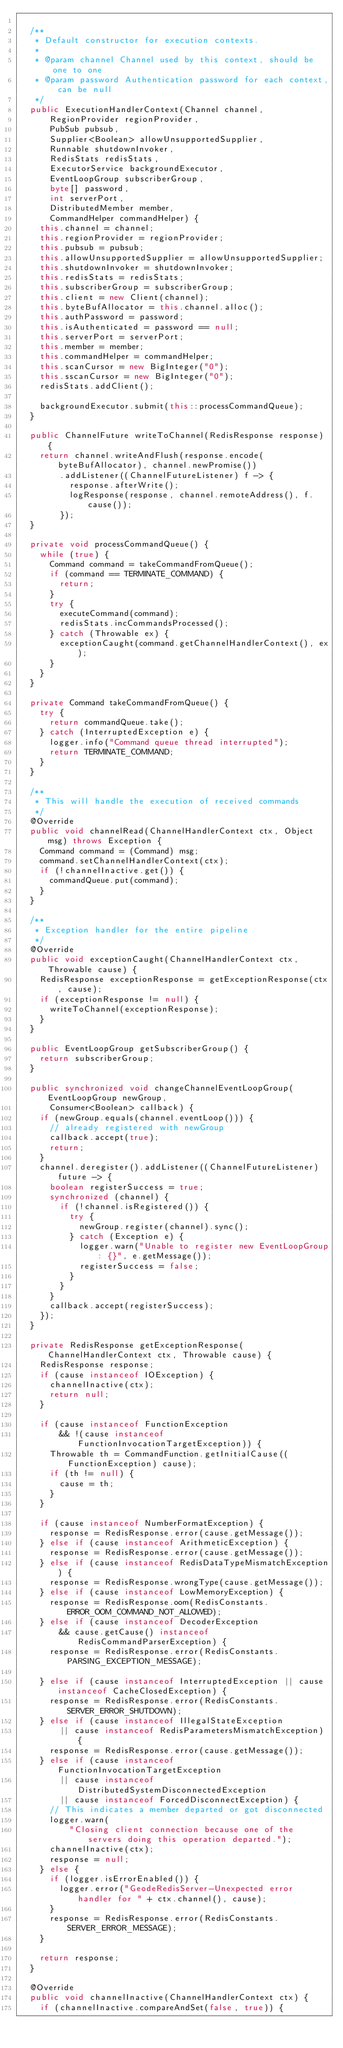<code> <loc_0><loc_0><loc_500><loc_500><_Java_>
  /**
   * Default constructor for execution contexts.
   *
   * @param channel Channel used by this context, should be one to one
   * @param password Authentication password for each context, can be null
   */
  public ExecutionHandlerContext(Channel channel,
      RegionProvider regionProvider,
      PubSub pubsub,
      Supplier<Boolean> allowUnsupportedSupplier,
      Runnable shutdownInvoker,
      RedisStats redisStats,
      ExecutorService backgroundExecutor,
      EventLoopGroup subscriberGroup,
      byte[] password,
      int serverPort,
      DistributedMember member,
      CommandHelper commandHelper) {
    this.channel = channel;
    this.regionProvider = regionProvider;
    this.pubsub = pubsub;
    this.allowUnsupportedSupplier = allowUnsupportedSupplier;
    this.shutdownInvoker = shutdownInvoker;
    this.redisStats = redisStats;
    this.subscriberGroup = subscriberGroup;
    this.client = new Client(channel);
    this.byteBufAllocator = this.channel.alloc();
    this.authPassword = password;
    this.isAuthenticated = password == null;
    this.serverPort = serverPort;
    this.member = member;
    this.commandHelper = commandHelper;
    this.scanCursor = new BigInteger("0");
    this.sscanCursor = new BigInteger("0");
    redisStats.addClient();

    backgroundExecutor.submit(this::processCommandQueue);
  }

  public ChannelFuture writeToChannel(RedisResponse response) {
    return channel.writeAndFlush(response.encode(byteBufAllocator), channel.newPromise())
        .addListener((ChannelFutureListener) f -> {
          response.afterWrite();
          logResponse(response, channel.remoteAddress(), f.cause());
        });
  }

  private void processCommandQueue() {
    while (true) {
      Command command = takeCommandFromQueue();
      if (command == TERMINATE_COMMAND) {
        return;
      }
      try {
        executeCommand(command);
        redisStats.incCommandsProcessed();
      } catch (Throwable ex) {
        exceptionCaught(command.getChannelHandlerContext(), ex);
      }
    }
  }

  private Command takeCommandFromQueue() {
    try {
      return commandQueue.take();
    } catch (InterruptedException e) {
      logger.info("Command queue thread interrupted");
      return TERMINATE_COMMAND;
    }
  }

  /**
   * This will handle the execution of received commands
   */
  @Override
  public void channelRead(ChannelHandlerContext ctx, Object msg) throws Exception {
    Command command = (Command) msg;
    command.setChannelHandlerContext(ctx);
    if (!channelInactive.get()) {
      commandQueue.put(command);
    }
  }

  /**
   * Exception handler for the entire pipeline
   */
  @Override
  public void exceptionCaught(ChannelHandlerContext ctx, Throwable cause) {
    RedisResponse exceptionResponse = getExceptionResponse(ctx, cause);
    if (exceptionResponse != null) {
      writeToChannel(exceptionResponse);
    }
  }

  public EventLoopGroup getSubscriberGroup() {
    return subscriberGroup;
  }

  public synchronized void changeChannelEventLoopGroup(EventLoopGroup newGroup,
      Consumer<Boolean> callback) {
    if (newGroup.equals(channel.eventLoop())) {
      // already registered with newGroup
      callback.accept(true);
      return;
    }
    channel.deregister().addListener((ChannelFutureListener) future -> {
      boolean registerSuccess = true;
      synchronized (channel) {
        if (!channel.isRegistered()) {
          try {
            newGroup.register(channel).sync();
          } catch (Exception e) {
            logger.warn("Unable to register new EventLoopGroup: {}", e.getMessage());
            registerSuccess = false;
          }
        }
      }
      callback.accept(registerSuccess);
    });
  }

  private RedisResponse getExceptionResponse(ChannelHandlerContext ctx, Throwable cause) {
    RedisResponse response;
    if (cause instanceof IOException) {
      channelInactive(ctx);
      return null;
    }

    if (cause instanceof FunctionException
        && !(cause instanceof FunctionInvocationTargetException)) {
      Throwable th = CommandFunction.getInitialCause((FunctionException) cause);
      if (th != null) {
        cause = th;
      }
    }

    if (cause instanceof NumberFormatException) {
      response = RedisResponse.error(cause.getMessage());
    } else if (cause instanceof ArithmeticException) {
      response = RedisResponse.error(cause.getMessage());
    } else if (cause instanceof RedisDataTypeMismatchException) {
      response = RedisResponse.wrongType(cause.getMessage());
    } else if (cause instanceof LowMemoryException) {
      response = RedisResponse.oom(RedisConstants.ERROR_OOM_COMMAND_NOT_ALLOWED);
    } else if (cause instanceof DecoderException
        && cause.getCause() instanceof RedisCommandParserException) {
      response = RedisResponse.error(RedisConstants.PARSING_EXCEPTION_MESSAGE);

    } else if (cause instanceof InterruptedException || cause instanceof CacheClosedException) {
      response = RedisResponse.error(RedisConstants.SERVER_ERROR_SHUTDOWN);
    } else if (cause instanceof IllegalStateException
        || cause instanceof RedisParametersMismatchException) {
      response = RedisResponse.error(cause.getMessage());
    } else if (cause instanceof FunctionInvocationTargetException
        || cause instanceof DistributedSystemDisconnectedException
        || cause instanceof ForcedDisconnectException) {
      // This indicates a member departed or got disconnected
      logger.warn(
          "Closing client connection because one of the servers doing this operation departed.");
      channelInactive(ctx);
      response = null;
    } else {
      if (logger.isErrorEnabled()) {
        logger.error("GeodeRedisServer-Unexpected error handler for " + ctx.channel(), cause);
      }
      response = RedisResponse.error(RedisConstants.SERVER_ERROR_MESSAGE);
    }

    return response;
  }

  @Override
  public void channelInactive(ChannelHandlerContext ctx) {
    if (channelInactive.compareAndSet(false, true)) {</code> 